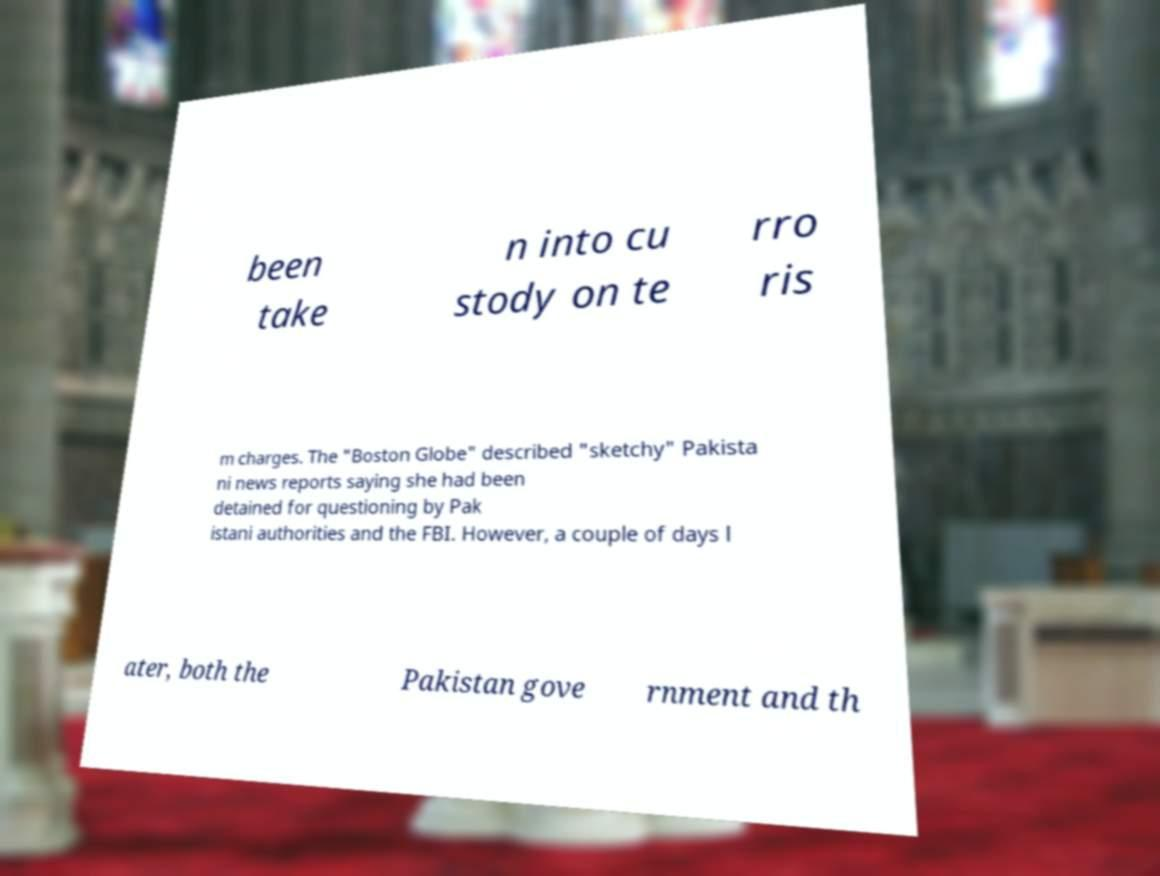Could you assist in decoding the text presented in this image and type it out clearly? been take n into cu stody on te rro ris m charges. The "Boston Globe" described "sketchy" Pakista ni news reports saying she had been detained for questioning by Pak istani authorities and the FBI. However, a couple of days l ater, both the Pakistan gove rnment and th 